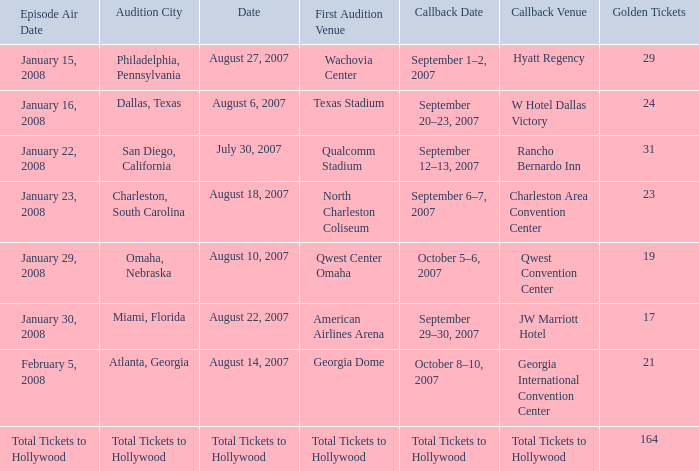What day has a callback Venue of total tickets to hollywood? Question Total Tickets to Hollywood. 